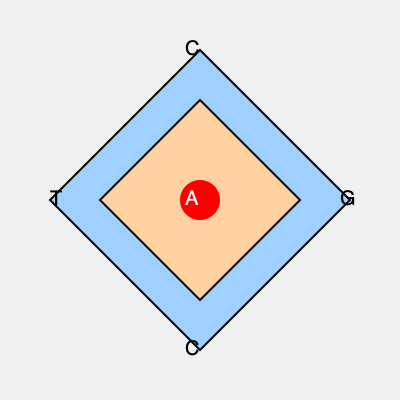In the diagram, two DNA sequences are represented as nested geometric shapes. The outer shape represents the reference sequence, while the inner shape represents a sequence to be aligned. If the inner shape needs to be rotated clockwise to align the nucleotide 'A' (red circle) with the 'G' on the right side of the outer shape, how many degrees of rotation are required? To solve this problem, we need to follow these steps:

1. Identify the current position of 'A' in the inner shape:
   - 'A' is at the center of the inner shape.

2. Identify the target position (G) in the outer shape:
   - 'G' is on the right side of the outer shape.

3. Determine the angular difference:
   - The inner shape is a square, which has 4 sides.
   - Each rotation from one side to the next is 90°.
   - To move from the center to the right side, we need to rotate by 90°.

4. Calculate the rotation:
   - Since we need to rotate clockwise, the rotation is positive.
   - The required rotation is 90°.

Therefore, to align the nucleotide 'A' with the 'G' on the right side of the outer shape, a clockwise rotation of 90° is required.
Answer: 90° 